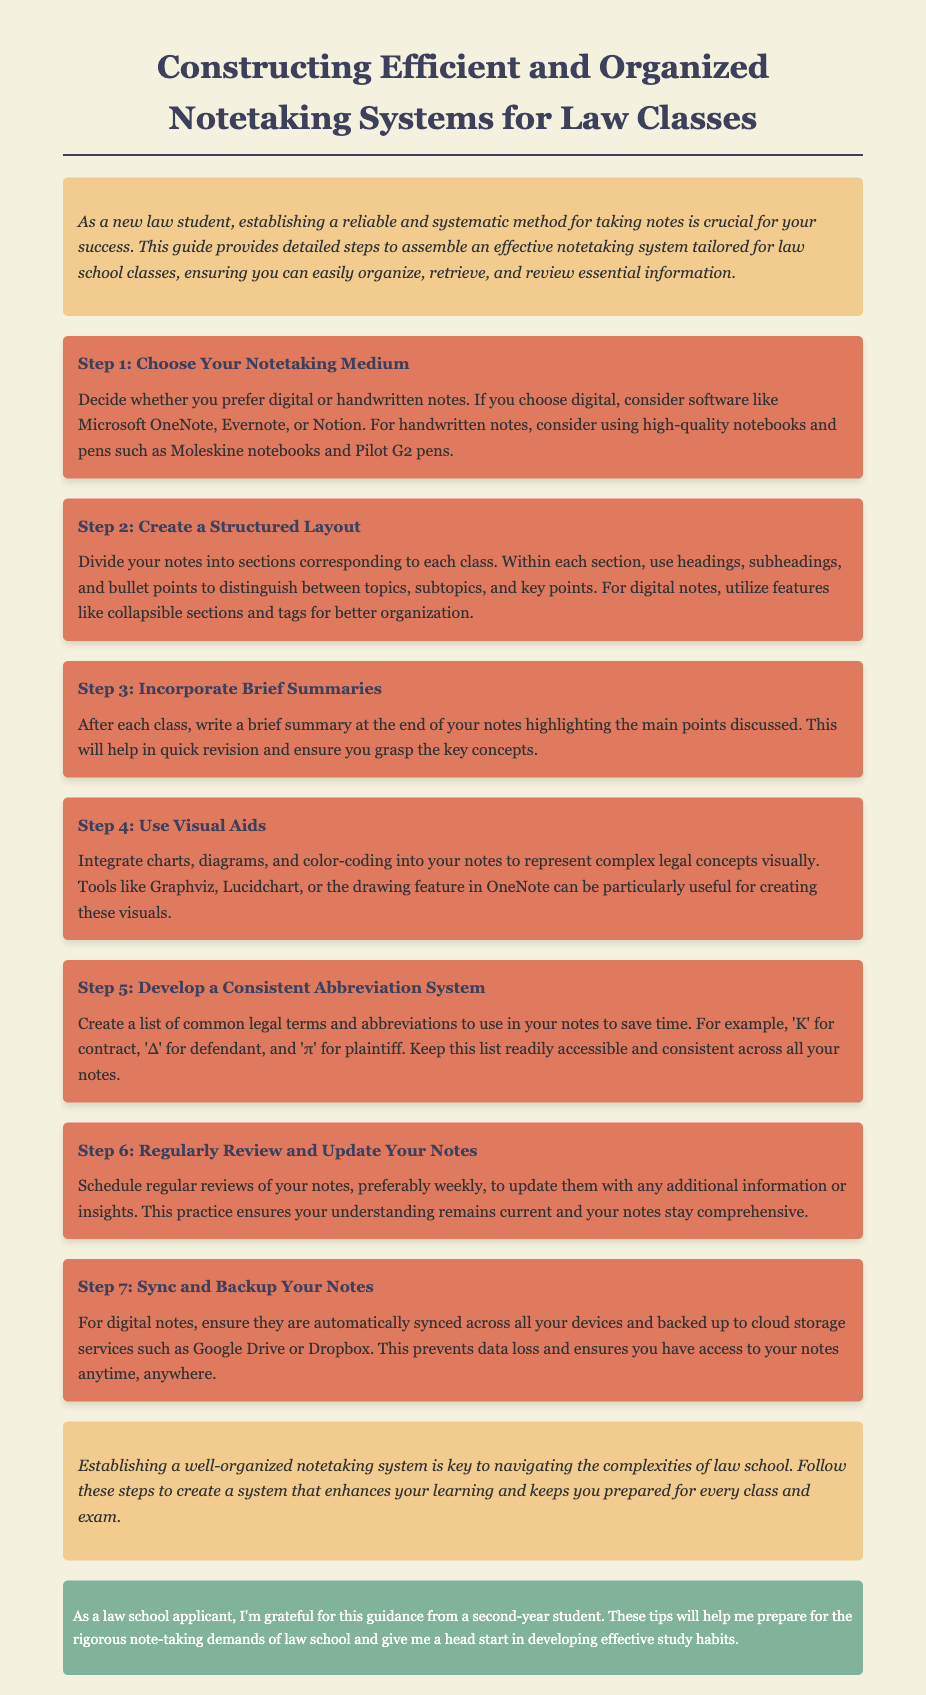What is the title of the document? The title of the document is provided in the <title> tag of the HTML, which is "Law School Notetaking Guide".
Answer: Law School Notetaking Guide What color is used for the headings in the document? The document specifies that headings are styled with the color code #3d405b according to the CSS provided.
Answer: #3d405b What step involves creating a list of legal abbreviations? The document outlines various steps for efficient notetaking, and step 5 specifically focuses on developing a consistent abbreviation system.
Answer: Step 5 Which software is suggested for digital note-taking? The document suggests several software options for digital notes, specifically mentioning Microsoft OneNote, Evernote, and Notion.
Answer: Microsoft OneNote How often should notes be reviewed according to the guide? The guide advises that notes should be reviewed regularly, specifically mentioning a preference for weekly reviews in step 6.
Answer: Weekly What should be integrated into notes to represent complex concepts? The document discusses incorporating visual aids, such as charts and diagrams, into the notes for better understanding of complex legal concepts.
Answer: Visual aids What is the main purpose of writing brief summaries after each class? The document explains that brief summaries are meant to highlight the main points discussed in class, aiding in quick revision and comprehension.
Answer: Quick revision What type of notes should be backed up to prevent data loss? The guide notes that digital notes, being the type of notes discussed, should be backed up to cloud storage services.
Answer: Digital notes 